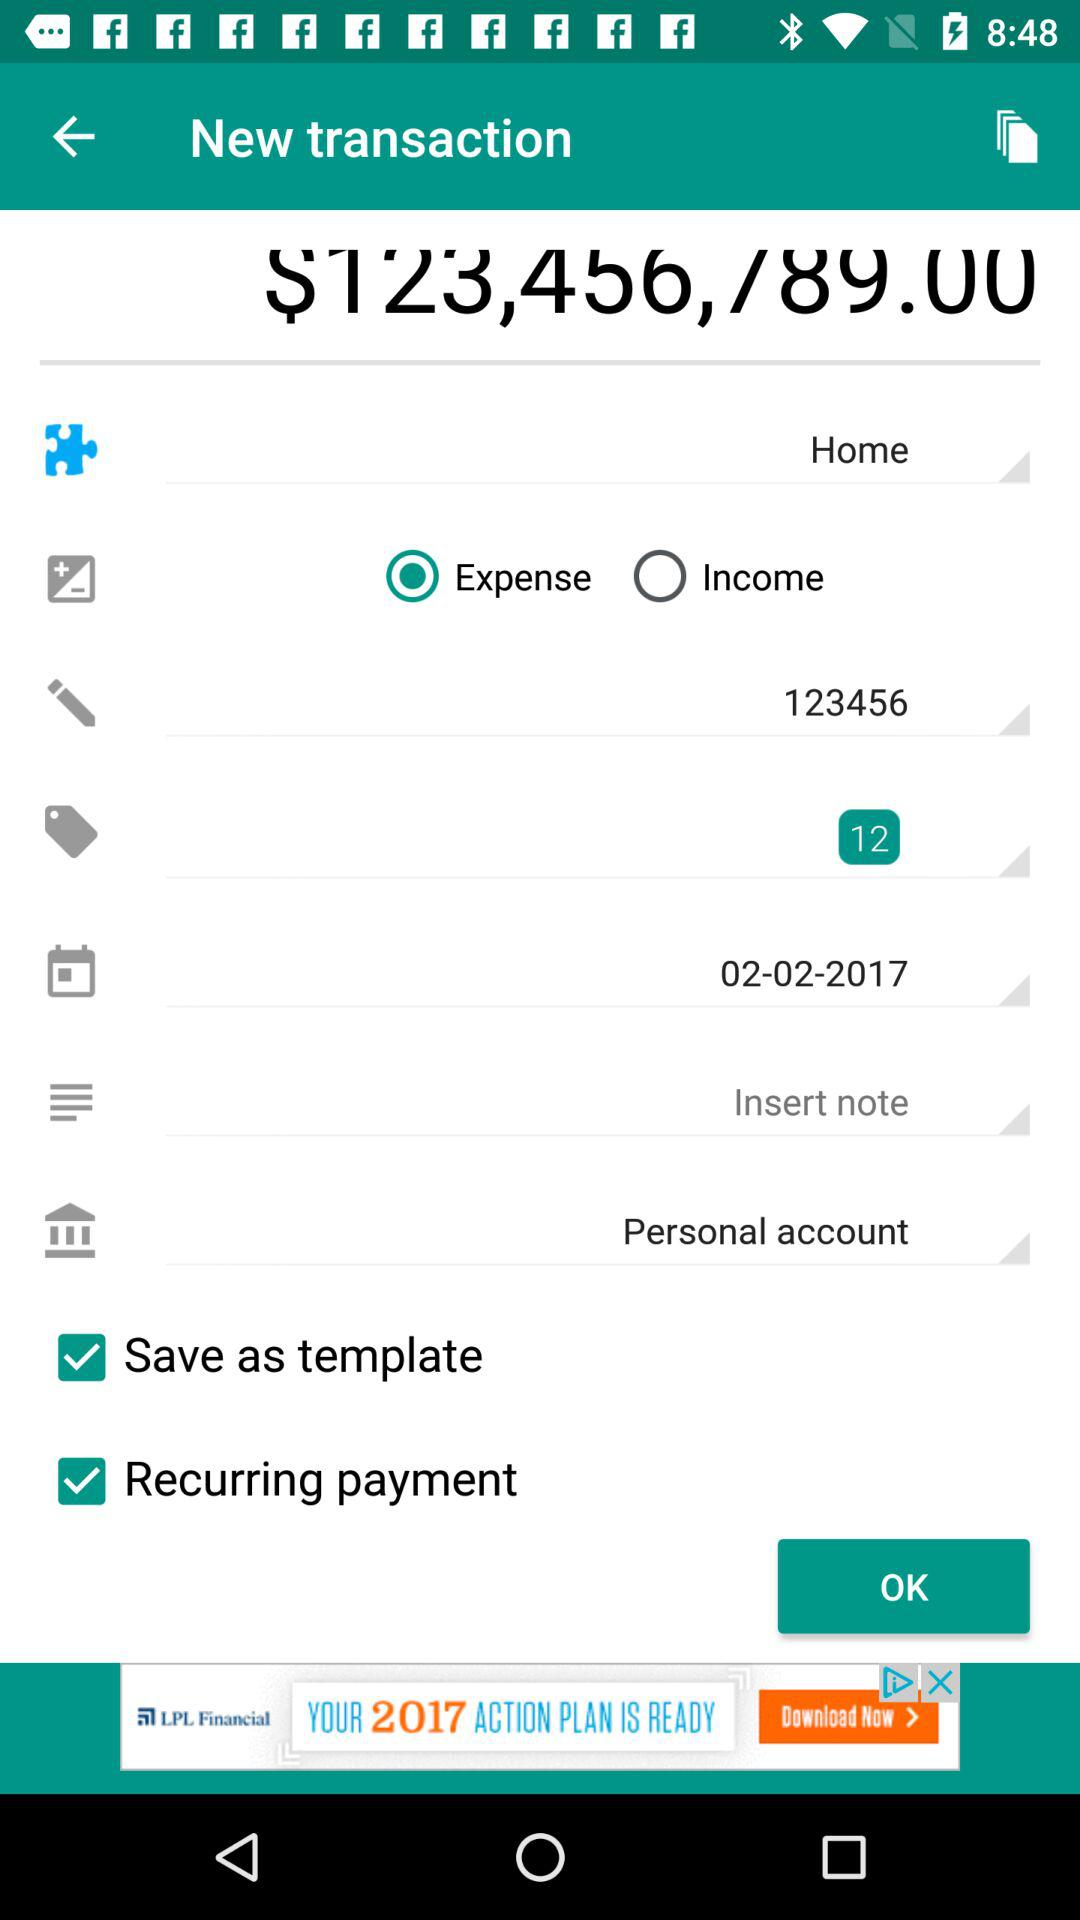What is the date of the transaction? The date of the transaction is February 02, 2017. 